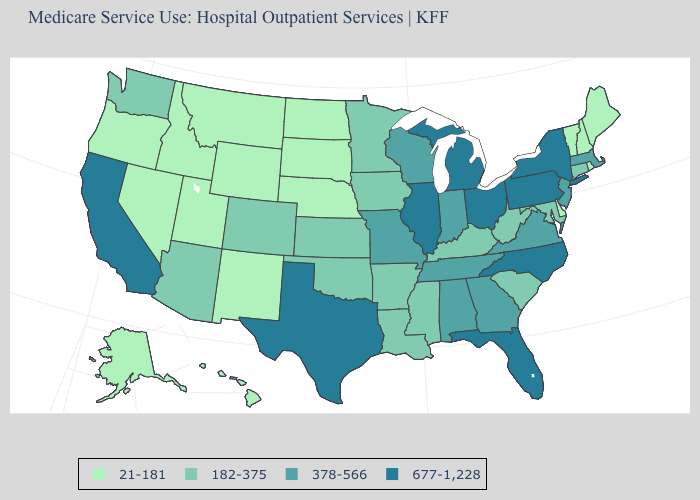Which states have the highest value in the USA?
Keep it brief. California, Florida, Illinois, Michigan, New York, North Carolina, Ohio, Pennsylvania, Texas. Which states have the highest value in the USA?
Write a very short answer. California, Florida, Illinois, Michigan, New York, North Carolina, Ohio, Pennsylvania, Texas. Does Florida have the same value as Pennsylvania?
Answer briefly. Yes. What is the value of North Dakota?
Give a very brief answer. 21-181. What is the value of Georgia?
Quick response, please. 378-566. Does Wyoming have the highest value in the West?
Keep it brief. No. Does the map have missing data?
Be succinct. No. What is the value of Illinois?
Concise answer only. 677-1,228. Name the states that have a value in the range 677-1,228?
Write a very short answer. California, Florida, Illinois, Michigan, New York, North Carolina, Ohio, Pennsylvania, Texas. What is the value of Missouri?
Short answer required. 378-566. Does the map have missing data?
Short answer required. No. Among the states that border Kansas , which have the lowest value?
Give a very brief answer. Nebraska. Does Hawaii have a lower value than Oregon?
Concise answer only. No. Does Alabama have the same value as Texas?
Quick response, please. No. Among the states that border Utah , which have the lowest value?
Quick response, please. Idaho, Nevada, New Mexico, Wyoming. 